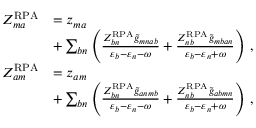<formula> <loc_0><loc_0><loc_500><loc_500>\begin{array} { r l } { Z _ { m a } ^ { R P A } } & { = z _ { m a } } \\ & { + \sum _ { b n } \left ( \frac { Z _ { b n } ^ { R P A } \tilde { g } _ { m n a b } } { \varepsilon _ { b } - \varepsilon _ { n } - \omega } + \frac { Z _ { n b } ^ { R P A } \tilde { g } _ { m b a n } } { \varepsilon _ { b } - \varepsilon _ { n } + \omega } \right ) \, , } \\ { Z _ { a m } ^ { R P A } } & { = z _ { a m } } \\ & { + \sum _ { b n } \left ( \frac { Z _ { b n } ^ { R P A } \tilde { g } _ { a n m b } } { \varepsilon _ { b } - \varepsilon _ { n } - \omega } + \frac { Z _ { n b } ^ { R P A } \tilde { g } _ { a b m n } } { \varepsilon _ { b } - \varepsilon _ { n } + \omega } \right ) \, , } \end{array}</formula> 